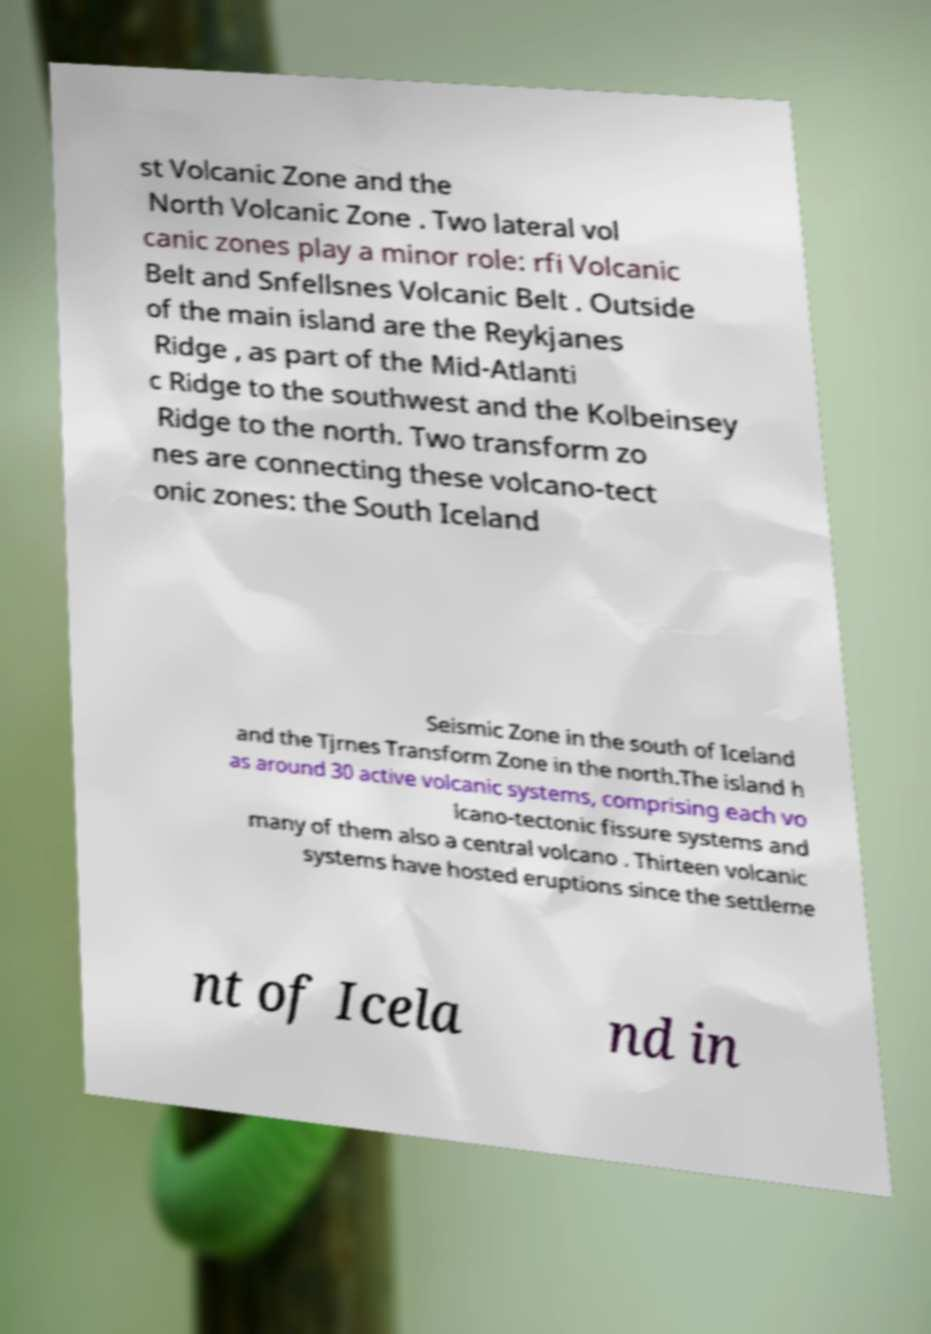For documentation purposes, I need the text within this image transcribed. Could you provide that? st Volcanic Zone and the North Volcanic Zone . Two lateral vol canic zones play a minor role: rfi Volcanic Belt and Snfellsnes Volcanic Belt . Outside of the main island are the Reykjanes Ridge , as part of the Mid-Atlanti c Ridge to the southwest and the Kolbeinsey Ridge to the north. Two transform zo nes are connecting these volcano-tect onic zones: the South Iceland Seismic Zone in the south of Iceland and the Tjrnes Transform Zone in the north.The island h as around 30 active volcanic systems, comprising each vo lcano-tectonic fissure systems and many of them also a central volcano . Thirteen volcanic systems have hosted eruptions since the settleme nt of Icela nd in 